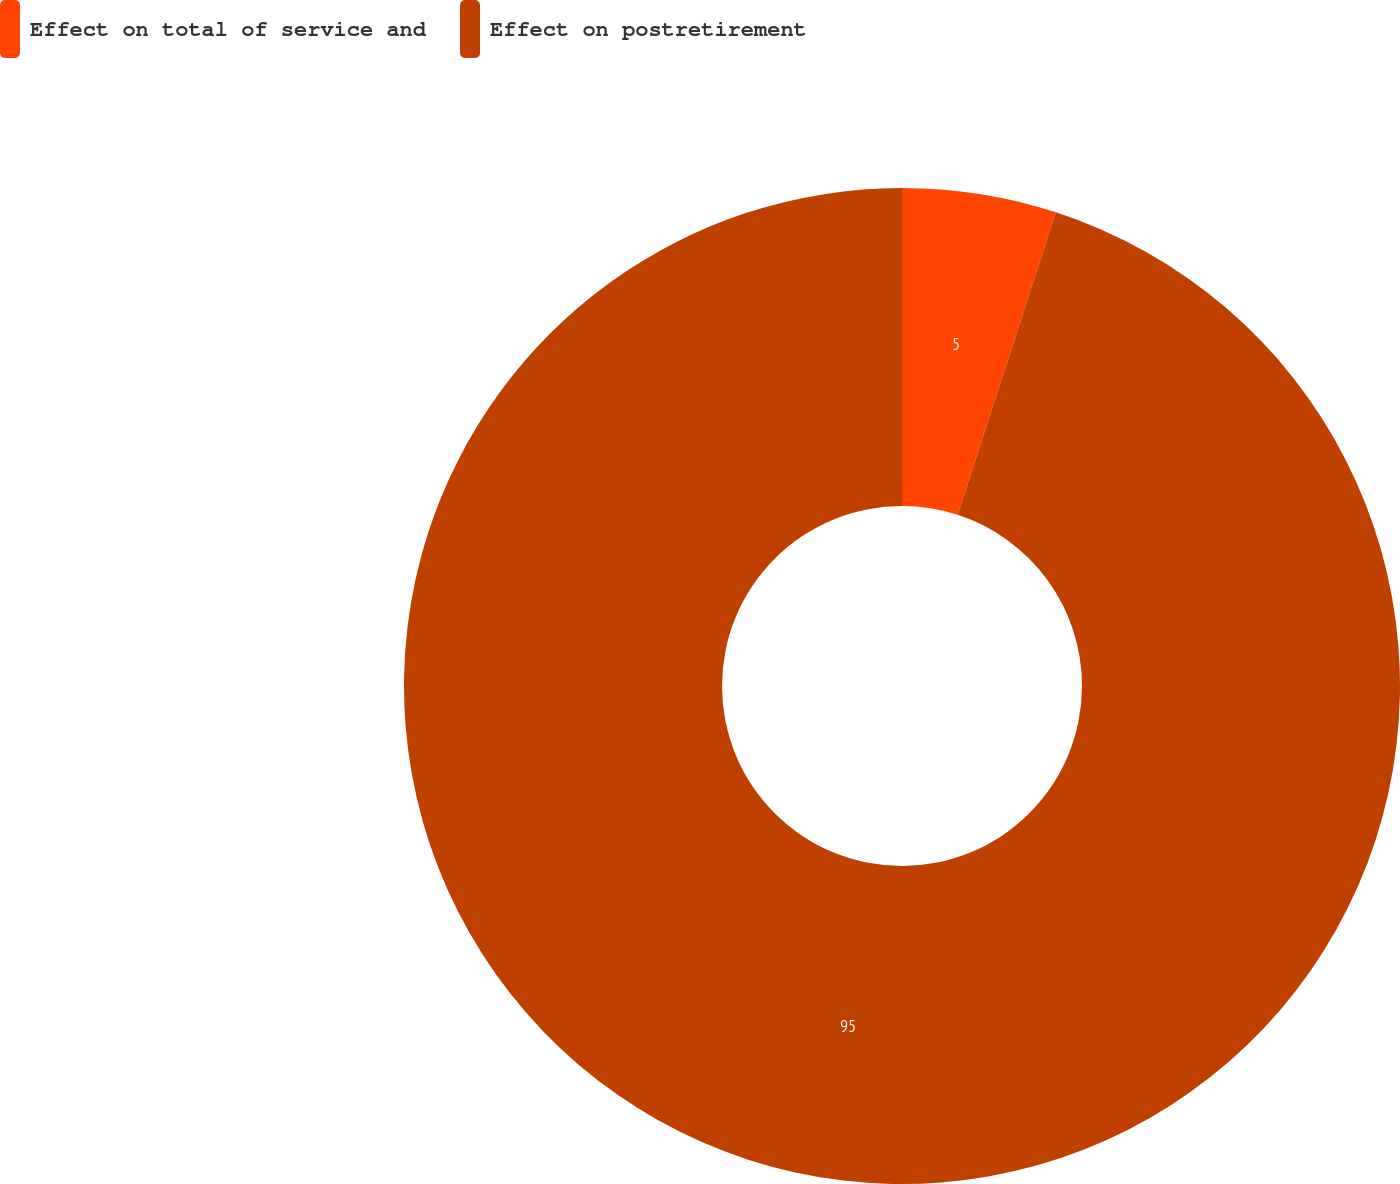Convert chart. <chart><loc_0><loc_0><loc_500><loc_500><pie_chart><fcel>Effect on total of service and<fcel>Effect on postretirement<nl><fcel>5.0%<fcel>95.0%<nl></chart> 